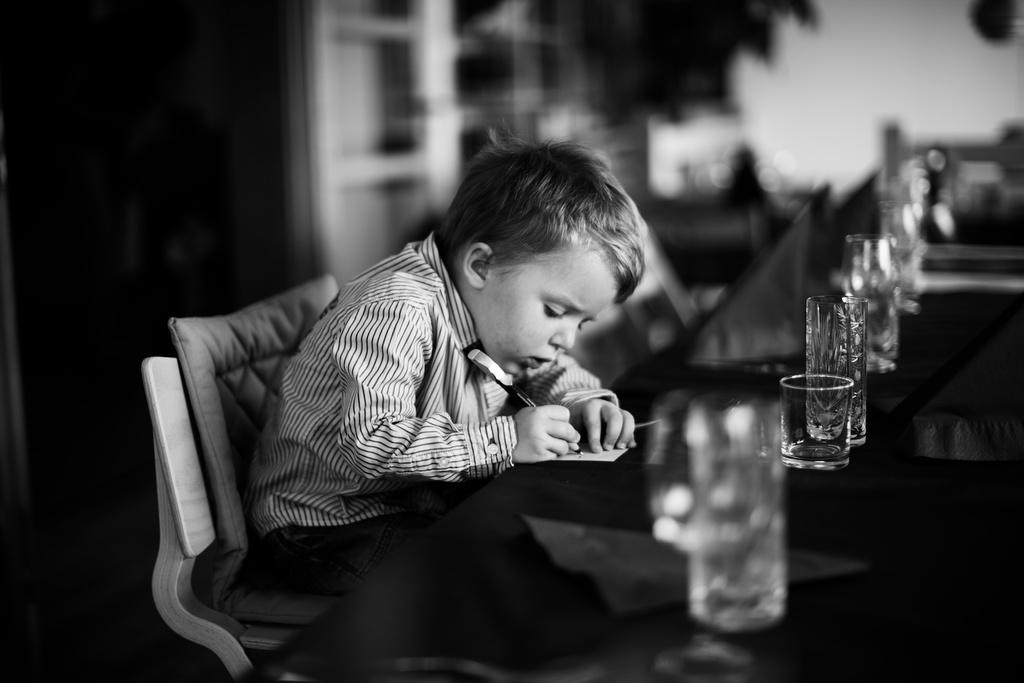What is the main subject of the image? The main subject of the image is a kid. What is the kid doing in the image? The kid is sitting in a chair and writing on a paper. Where is the paper located in the image? The paper is on a table. What type of potato can be seen growing near the kid in the image? There is no potato present in the image; it features a kid sitting in a chair and writing on a paper. How does the kid's breath affect the hydrant in the image? There is no hydrant present in the image, so it is not possible to determine how the kid's breath might affect it. 